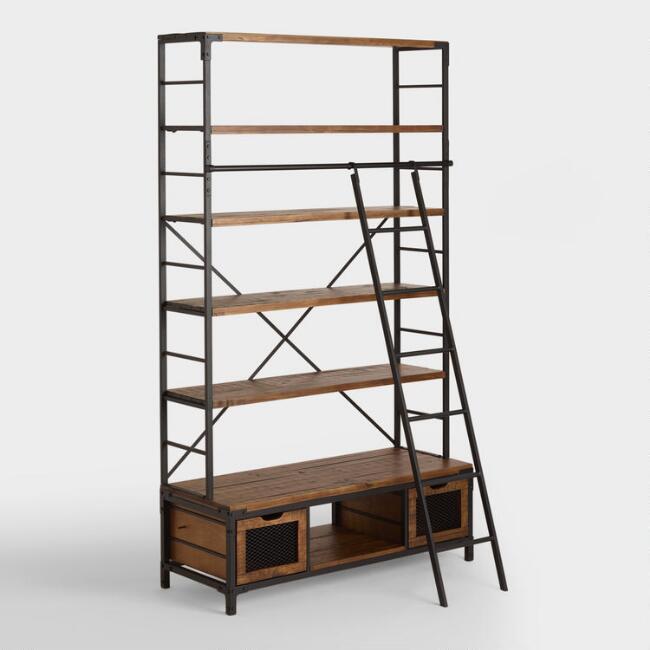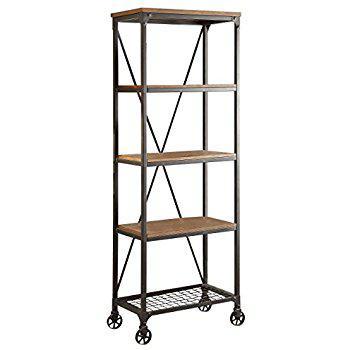The first image is the image on the left, the second image is the image on the right. Considering the images on both sides, is "One of the shelving units is up against a wall." valid? Answer yes or no. No. The first image is the image on the left, the second image is the image on the right. Analyze the images presented: Is the assertion "at least one bookshelf is empty" valid? Answer yes or no. Yes. 